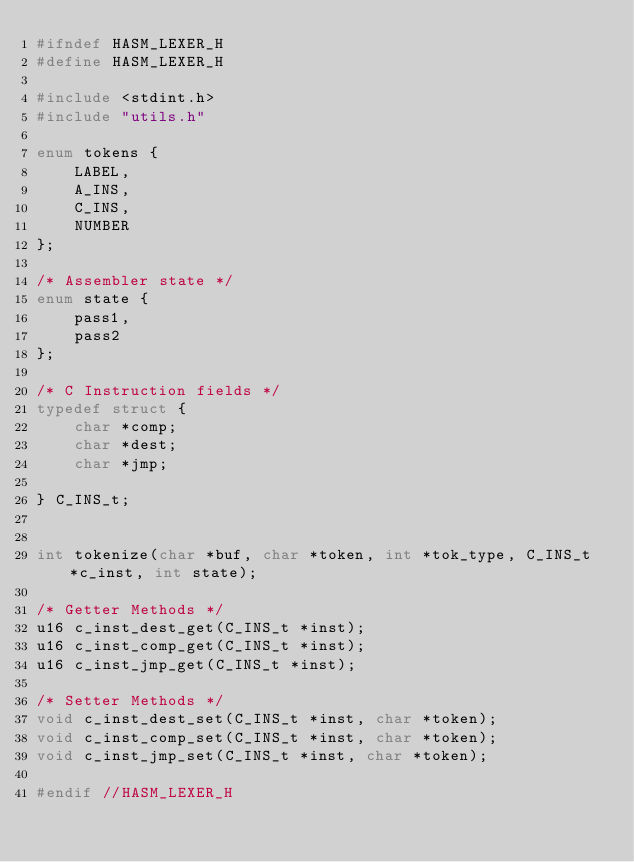Convert code to text. <code><loc_0><loc_0><loc_500><loc_500><_C_>#ifndef HASM_LEXER_H
#define HASM_LEXER_H

#include <stdint.h>
#include "utils.h"

enum tokens {
    LABEL,
    A_INS,
    C_INS,
    NUMBER
};

/* Assembler state */
enum state {
    pass1,
    pass2
};

/* C Instruction fields */
typedef struct {
    char *comp;
    char *dest;
    char *jmp;
    
} C_INS_t;


int tokenize(char *buf, char *token, int *tok_type, C_INS_t *c_inst, int state);

/* Getter Methods */
u16 c_inst_dest_get(C_INS_t *inst);
u16 c_inst_comp_get(C_INS_t *inst);
u16 c_inst_jmp_get(C_INS_t *inst);

/* Setter Methods */
void c_inst_dest_set(C_INS_t *inst, char *token);
void c_inst_comp_set(C_INS_t *inst, char *token);
void c_inst_jmp_set(C_INS_t *inst, char *token);

#endif //HASM_LEXER_H
</code> 